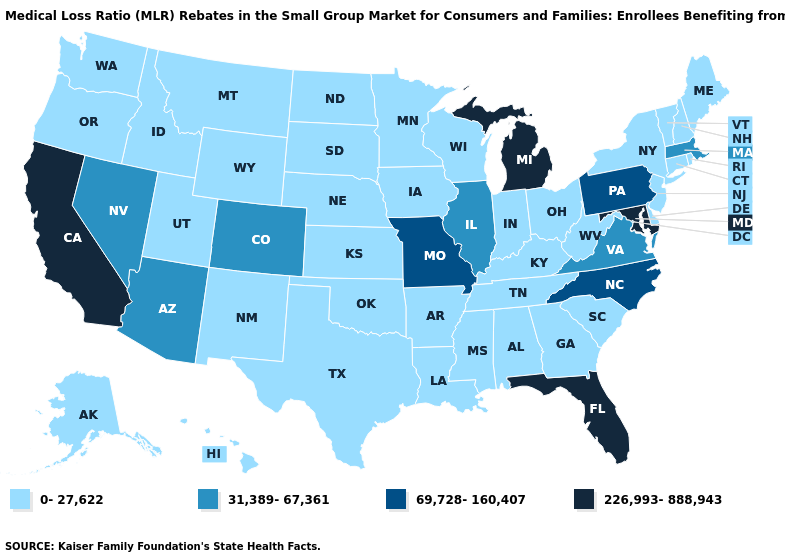What is the value of Illinois?
Write a very short answer. 31,389-67,361. What is the highest value in states that border Massachusetts?
Write a very short answer. 0-27,622. Does North Carolina have the lowest value in the South?
Write a very short answer. No. What is the lowest value in states that border Colorado?
Answer briefly. 0-27,622. Among the states that border Idaho , which have the lowest value?
Be succinct. Montana, Oregon, Utah, Washington, Wyoming. What is the lowest value in the USA?
Be succinct. 0-27,622. What is the value of South Carolina?
Answer briefly. 0-27,622. Is the legend a continuous bar?
Keep it brief. No. Name the states that have a value in the range 69,728-160,407?
Be succinct. Missouri, North Carolina, Pennsylvania. What is the highest value in the USA?
Short answer required. 226,993-888,943. Name the states that have a value in the range 69,728-160,407?
Concise answer only. Missouri, North Carolina, Pennsylvania. What is the highest value in the USA?
Quick response, please. 226,993-888,943. What is the value of North Dakota?
Short answer required. 0-27,622. What is the value of Wyoming?
Be succinct. 0-27,622. Name the states that have a value in the range 31,389-67,361?
Write a very short answer. Arizona, Colorado, Illinois, Massachusetts, Nevada, Virginia. 